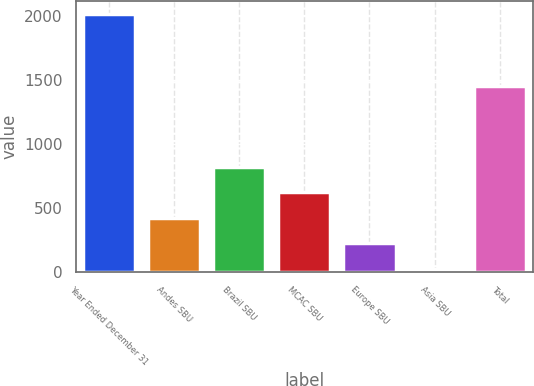<chart> <loc_0><loc_0><loc_500><loc_500><bar_chart><fcel>Year Ended December 31<fcel>Andes SBU<fcel>Brazil SBU<fcel>MCAC SBU<fcel>Europe SBU<fcel>Asia SBU<fcel>Total<nl><fcel>2014<fcel>422.8<fcel>820.6<fcel>621.7<fcel>223.9<fcel>25<fcel>1451<nl></chart> 